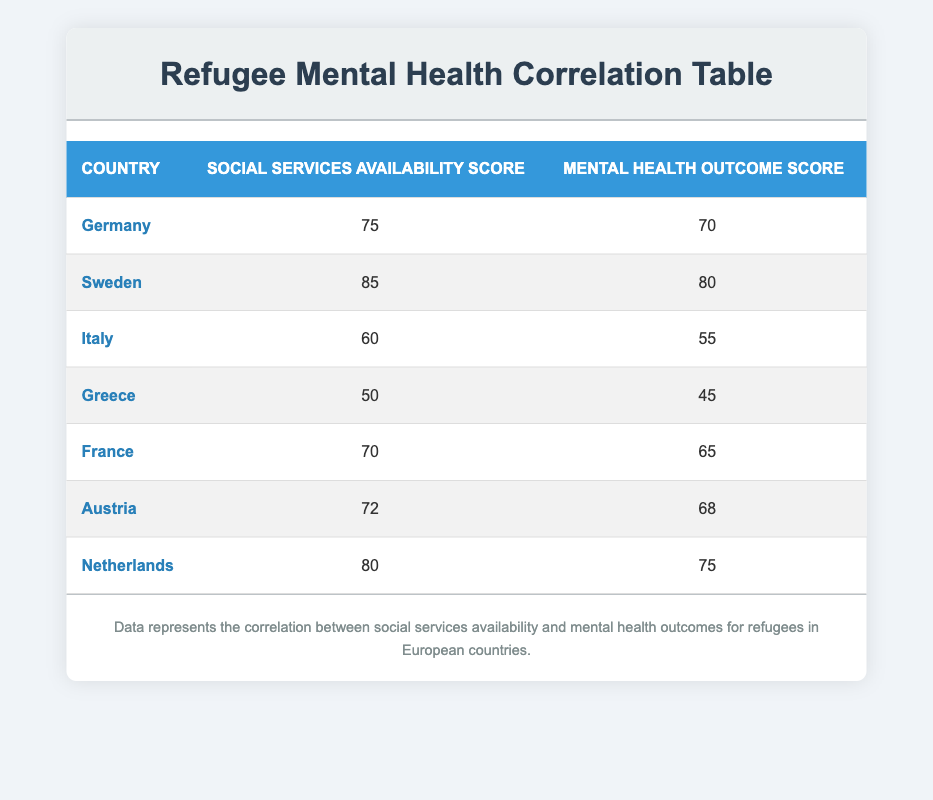What is the Social Services Availability Score for Sweden? The table shows that Sweden is listed, and the corresponding Social Services Availability Score is 85.
Answer: 85 Which country has the lowest Mental Health Outcome Score? By scanning the Mental Health Outcome Score column, Greece has the lowest score at 45.
Answer: Greece What is the difference between the Social Services Availability Score of Germany and Greece? From the table, Germany has a score of 75 and Greece has a score of 50. The difference is calculated as 75 - 50 = 25.
Answer: 25 Is the Mental Health Outcome Score for Austria greater than that of Italy? According to the table, Austria has a score of 68 while Italy has a score of 55. Since 68 is greater than 55, the answer is yes.
Answer: Yes What is the average Social Services Availability Score for the countries listed? The Social Services Availability Scores are 75, 85, 60, 50, 70, 72, and 80. Adding these scores gives a sum of 492. There are 7 countries, so the average is 492 / 7 ≈ 70.29.
Answer: 70.29 Which country has a Mental Health Outcome Score closest to the average of 68? To find the average Mental Health Outcome Score, we add the scores: 70, 80, 55, 45, 65, 68, and 75, giving a sum of 478. The average is 478 / 7 ≈ 68.29. The scores closest to this average are Germany with 70 and Austria with 68.
Answer: Germany and Austria Are there more countries with a Social Services Availability Score above 70 than below? The table shows that the countries with scores above 70 are Sweden, Netherlands, Germany, and Austria, totaling 4. The countries below are Italy, Greece, and France, totaling 3. Therefore, there are more countries above 70.
Answer: Yes What is the ratio of the highest Mental Health Outcome Score to the lowest? The highest score is for Sweden at 80, and the lowest is Greece at 45. The ratio is therefore 80:45 or simplified to 16:9.
Answer: 16:9 Has any country with a Social Services Availability Score below 60 achieved a Mental Health Outcome Score of 50 or higher? Italy has a Social Services Availability Score of 60 and a Mental Health Outcome Score of 55, but Greece with a score of 50 is below 60 and has a Mental Health Outcome Score lower than 50. There are no countries below 60 achieving above 50.
Answer: No 